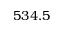Convert formula to latex. <formula><loc_0><loc_0><loc_500><loc_500>5 3 4 . 5</formula> 